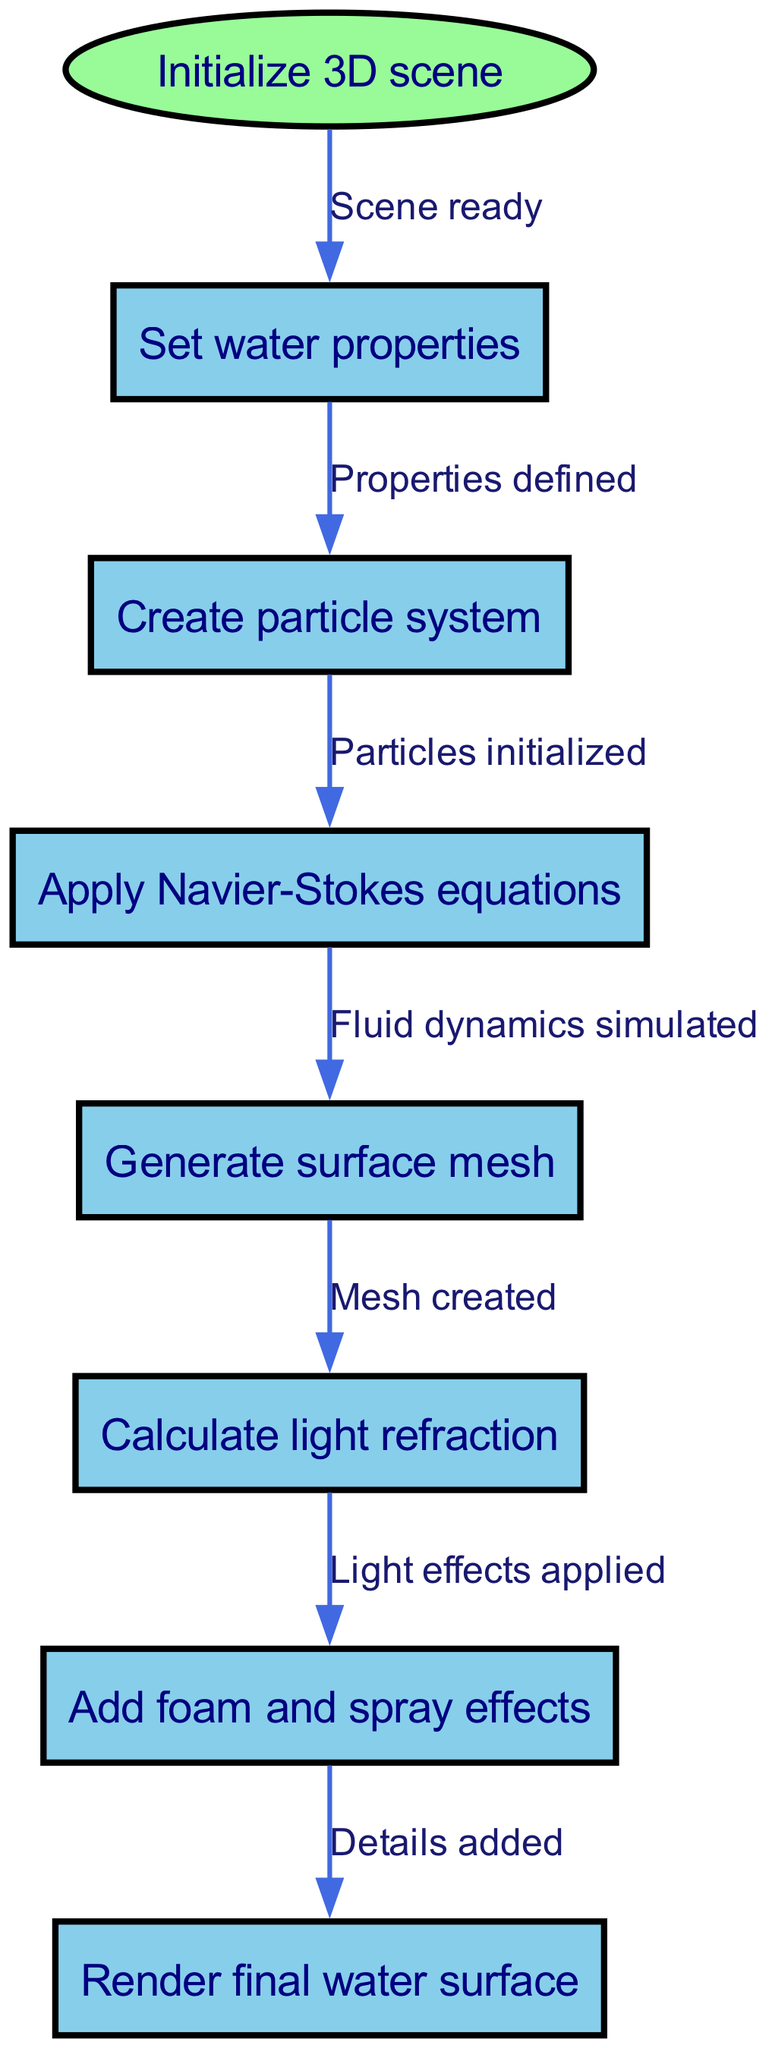What is the first node in the flowchart? The first node in the flowchart is labeled "Initialize 3D scene," which is the starting point for the algorithm.
Answer: Initialize 3D scene How many nodes are present in the diagram? By counting the nodes listed in the diagram, we can see that there are a total of 7 nodes, including the starting node.
Answer: 7 What is the last step in the rendering algorithm? The last step in the flowchart is "Render final water surface," indicating that this is the final action taken in the process.
Answer: Render final water surface What labels are used on the edges leading from "Apply Navier-Stokes equations"? The edge leading from "Apply Navier-Stokes equations" to "Generate surface mesh" is labeled "Fluid dynamics simulated." This indicates the result of applying those equations.
Answer: Fluid dynamics simulated What node directly follows "Add foam and spray effects"? The node that directly follows "Add foam and spray effects" is "Render final water surface," which signifies the next action taken after adding details.
Answer: Render final water surface Which two nodes are connected by the label "Light effects applied"? The nodes connected by the label "Light effects applied" are "Calculate light refraction" and "Add foam and spray effects," showing the relationship of applying light effects to the water rendering process.
Answer: Calculate light refraction, Add foam and spray effects Identify the node that immediately comes before "Generate surface mesh." The node that immediately precedes "Generate surface mesh" is "Apply Navier-Stokes equations," indicating that fluid dynamics must be simulated first to create the surface mesh.
Answer: Apply Navier-Stokes equations If the water properties are not set, which node cannot be initiated? If the water properties are not set, the node "Create particle system" cannot be initiated, as it depends on the prior step of defining water properties.
Answer: Create particle system What is the flow direction of the diagram? The flow direction of the diagram is top to bottom, as indicated by the ranking direction specified in the diagram.
Answer: Top to bottom 